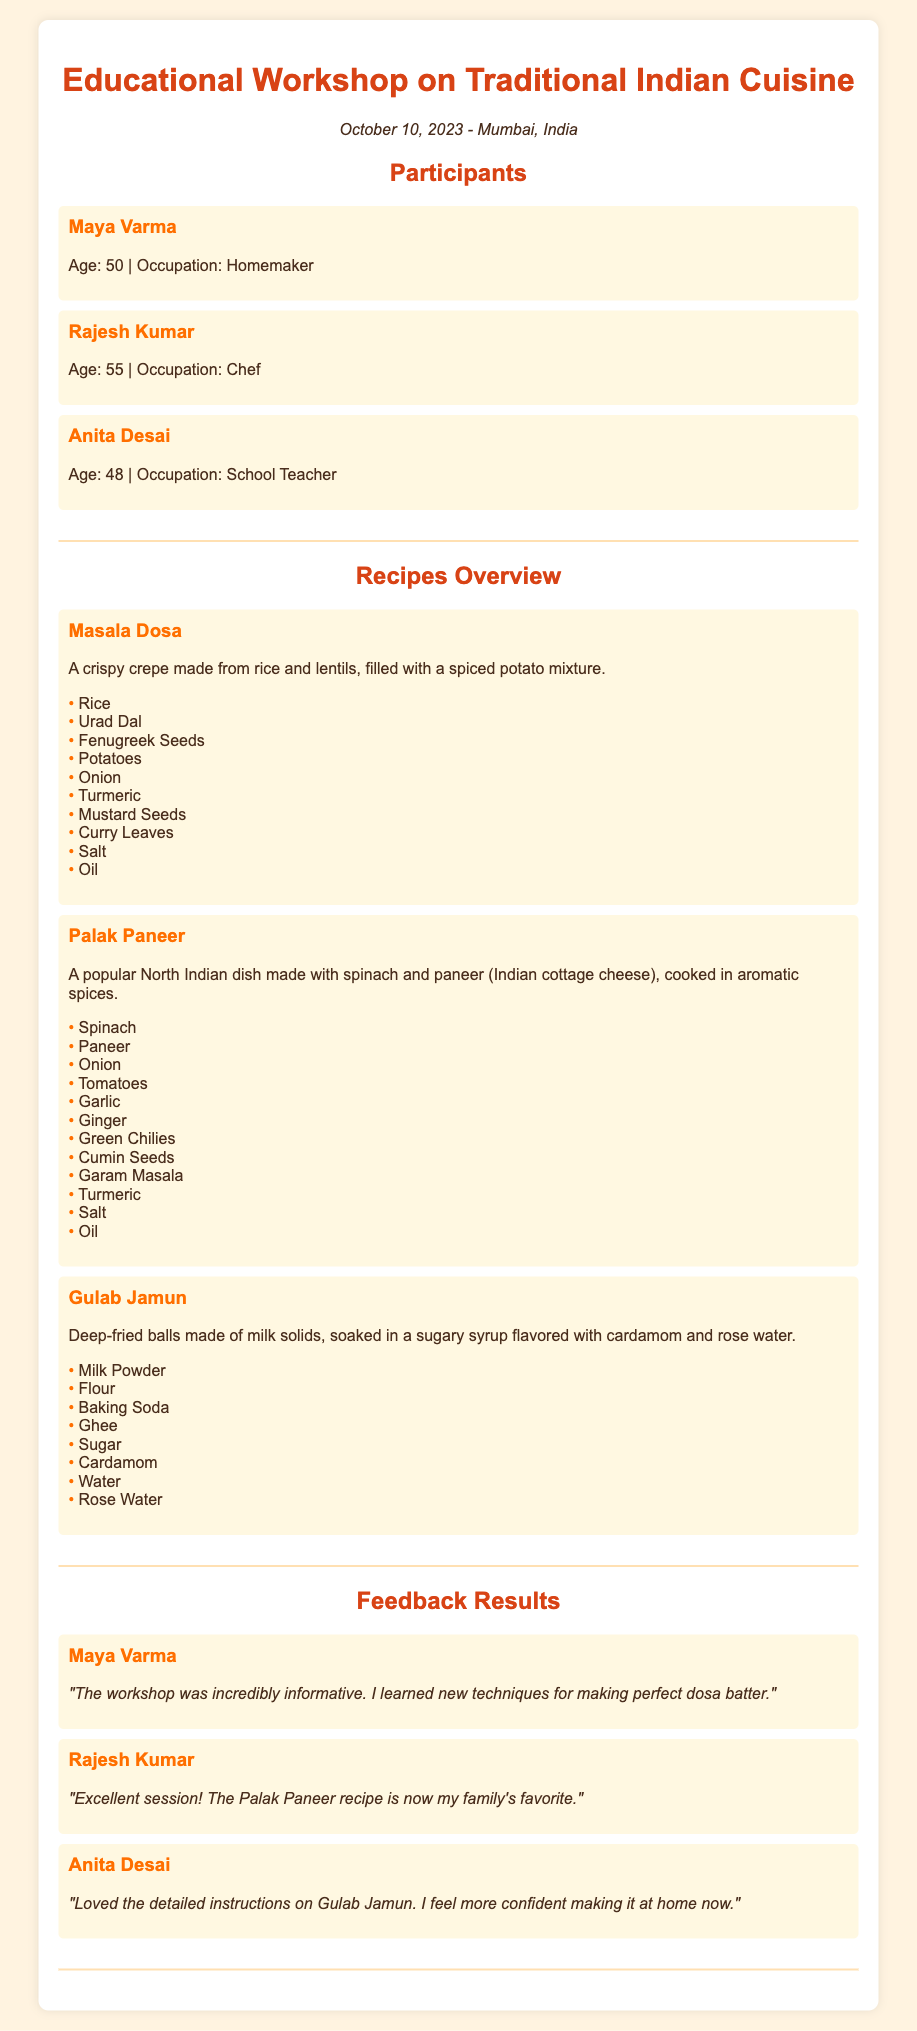What is the date of the workshop? The date of the workshop is mentioned at the top of the document: October 10, 2023.
Answer: October 10, 2023 Who is the chef participant? The document provides a list of participants, including their occupations. Rajesh Kumar is identified as the chef.
Answer: Rajesh Kumar How many recipes are featured in the workshop overview? The document outlines three different recipes that are part of the workshop.
Answer: Three What is the main ingredient in Masala Dosa? The recipe overview for Masala Dosa lists rice as one of the main ingredients.
Answer: Rice What did Maya Varma learn from the workshop? Feedback from Maya Varma indicates that she learned techniques for making perfect dosa batter.
Answer: Techniques for making perfect dosa batter Which recipe became the family's favorite for Rajesh Kumar? The feedback from Rajesh Kumar states that the Palak Paneer recipe is now his family's favorite.
Answer: Palak Paneer How did Anita Desai feel about the Gulab Jamun instructions? Anita Desai's feedback describes her feeling more confident about making Gulab Jamun.
Answer: More confident What city hosted the workshop? The location of the workshop is specified at the top of the document as Mumbai.
Answer: Mumbai What flavoring is used in Gulab Jamun syrup? The recipe for Gulab Jamun mentions rose water as a flavoring in the sugary syrup.
Answer: Rose water 